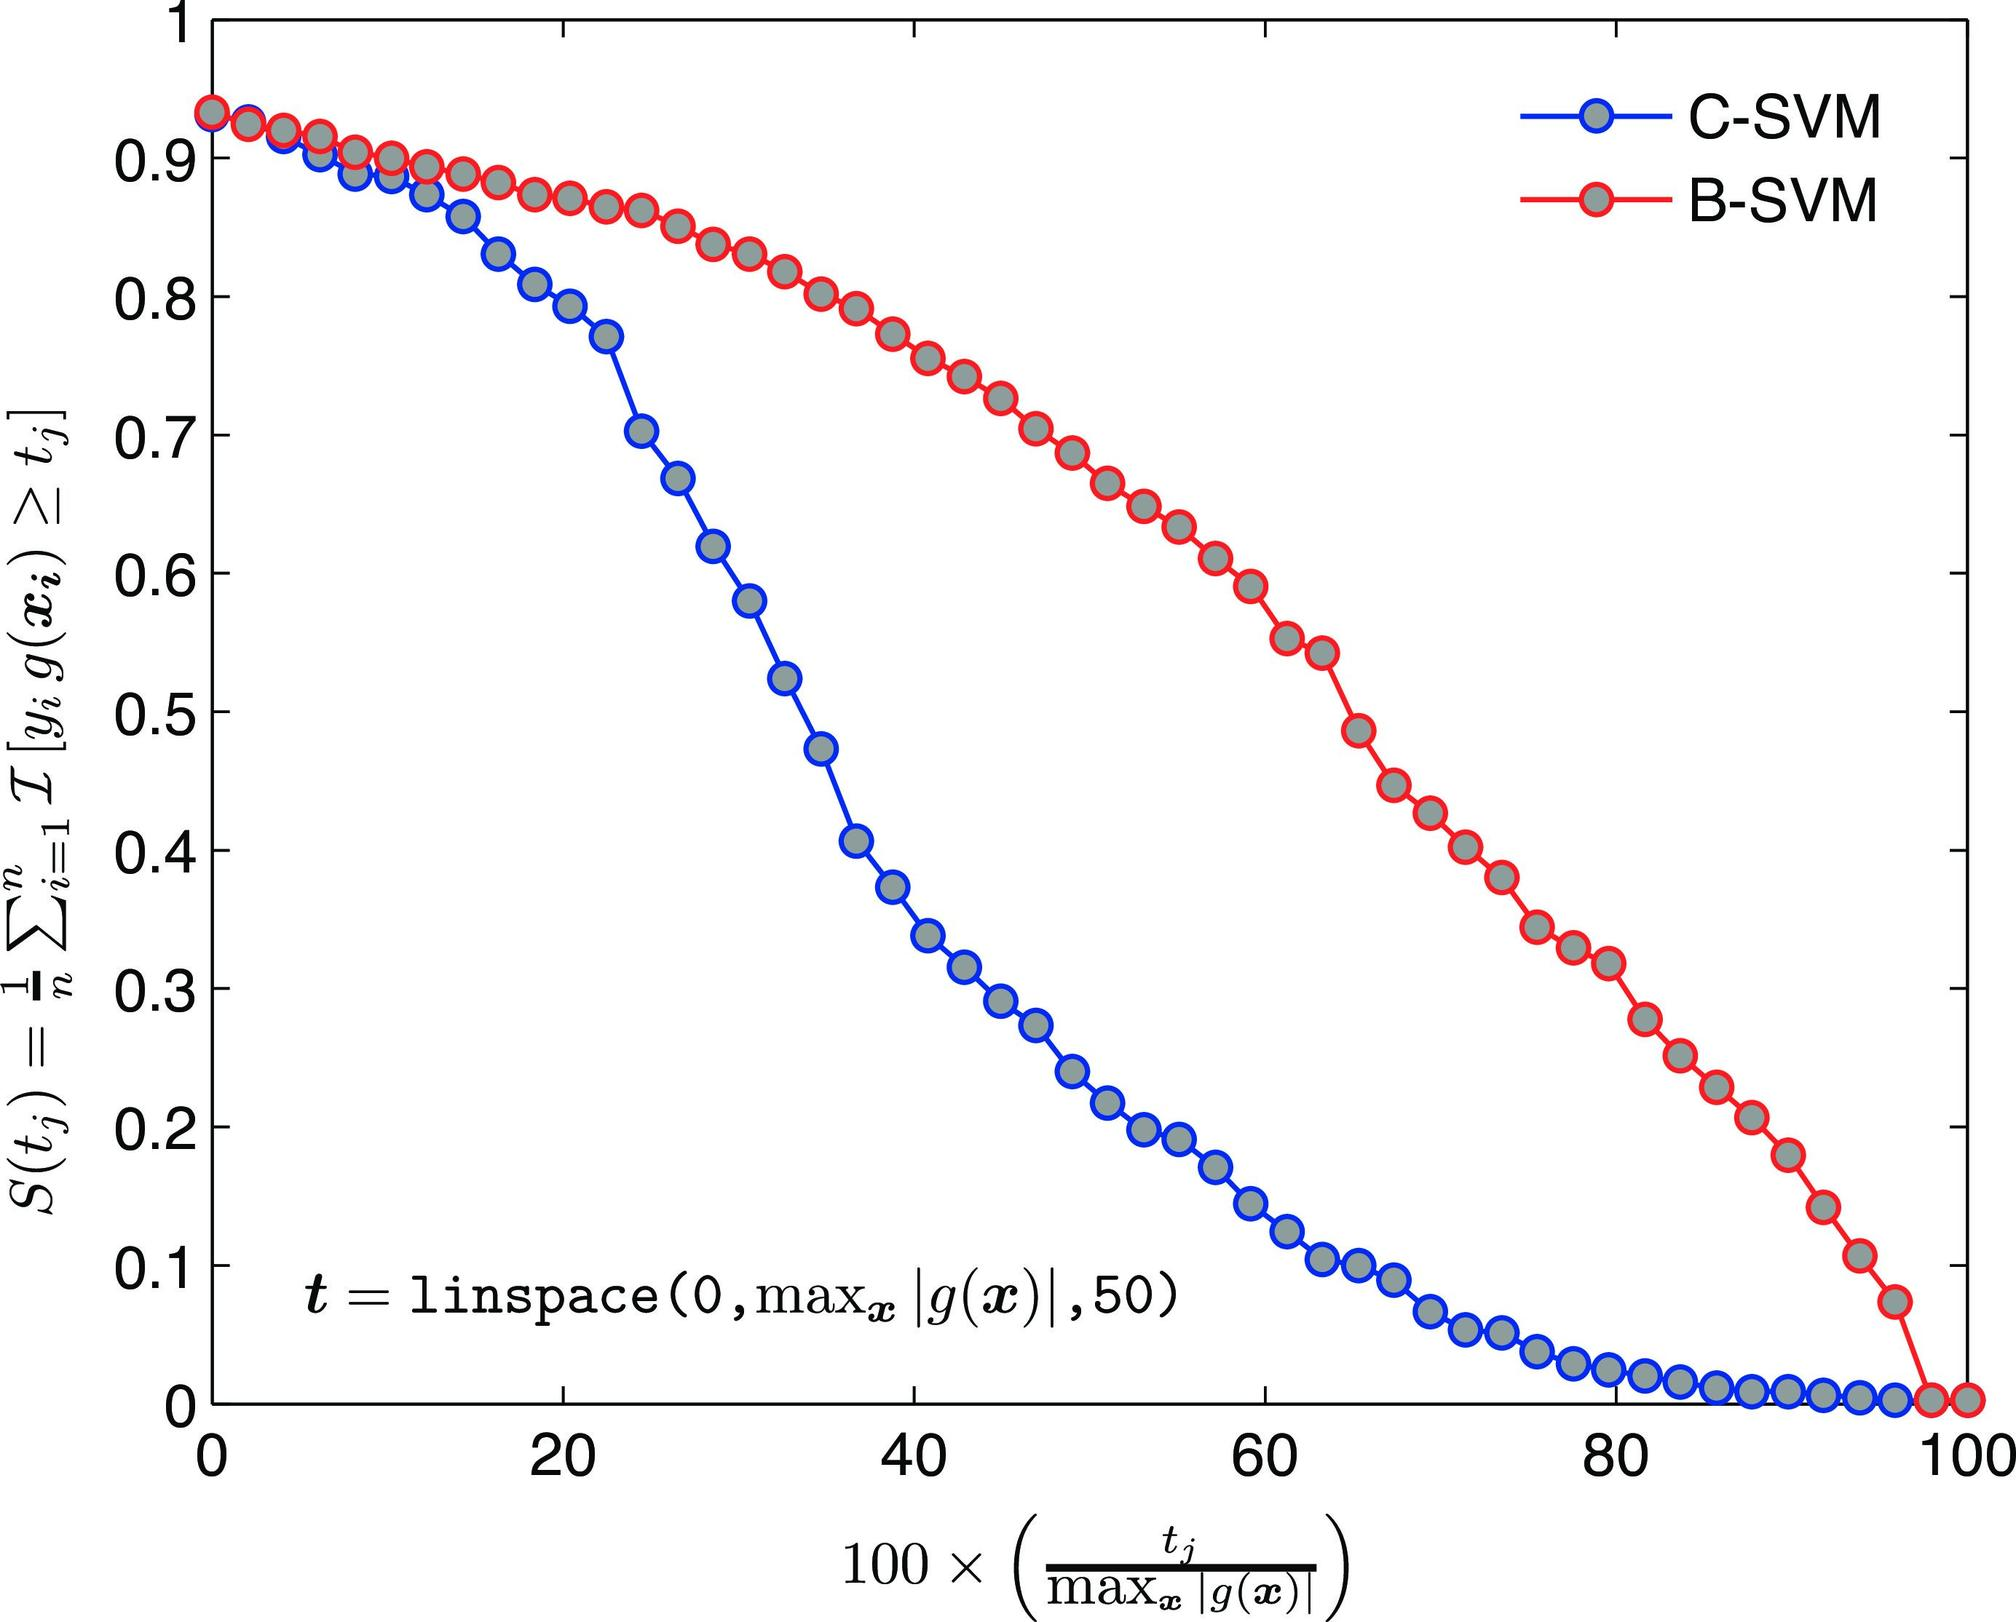Based on the figure, at approximately what value of \( t \) does B-SVM begin to outperform C-SVM? A) 20 B) 40 C) 60 D) 80 The intersection point of the two curves represents the value of \( t \) where the performances of C-SVM and B-SVM are equal. After this point, the B-SVM curve is above the C-SVM curve, indicating better performance. The intersection appears to occur just before the value of 40 on the x-axis. Therefore, the correct answer is B. 